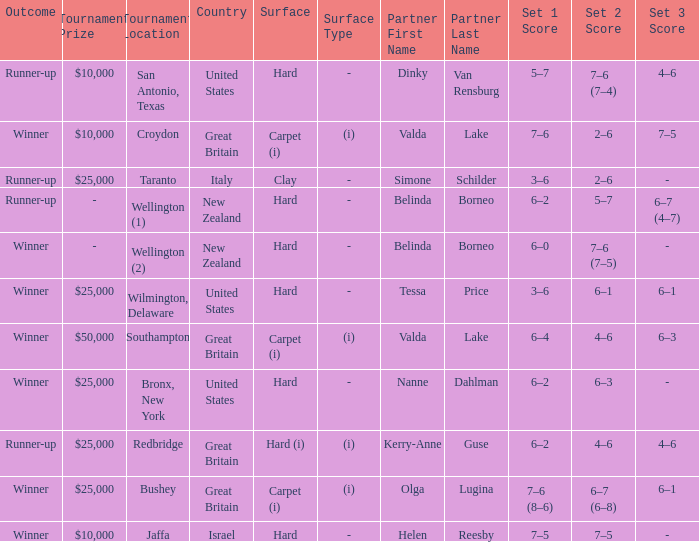What was the final score for the match with a partnering of Tessa Price? 3–6, 6–1, 6–1. 